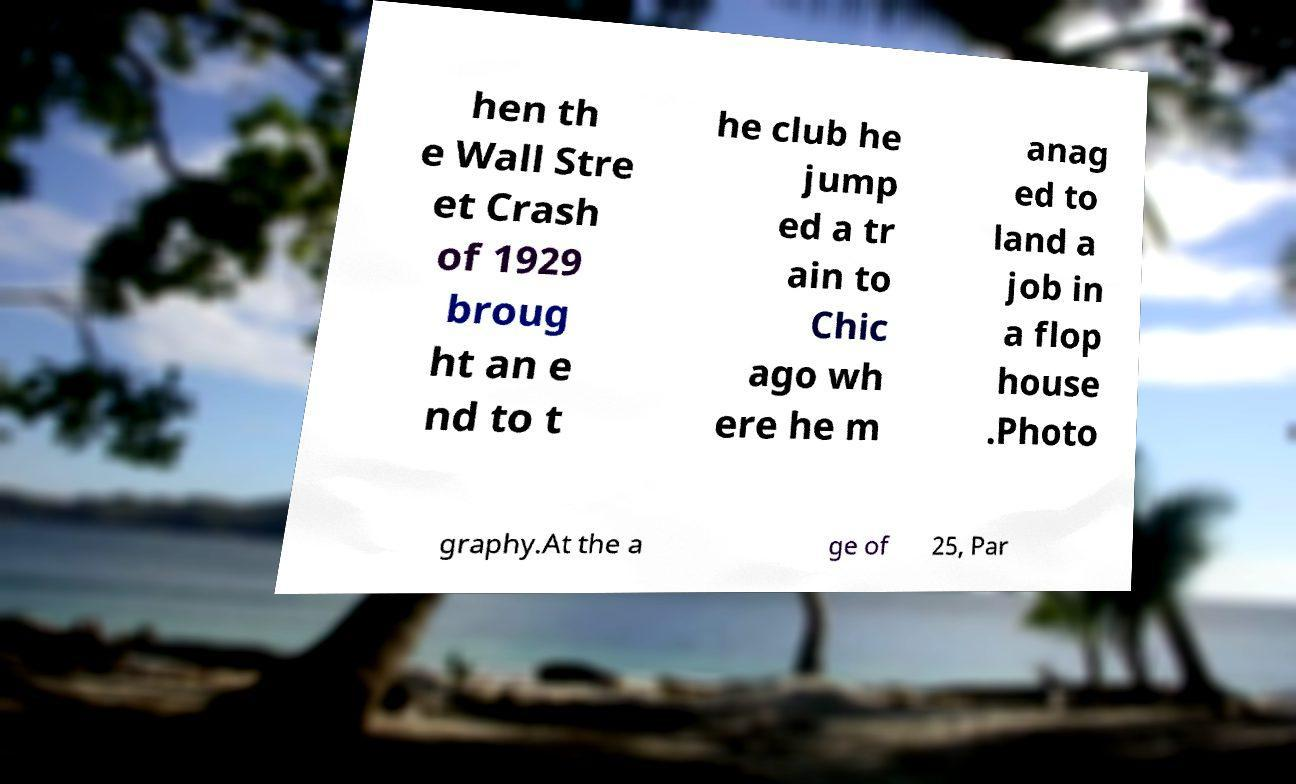Can you read and provide the text displayed in the image?This photo seems to have some interesting text. Can you extract and type it out for me? hen th e Wall Stre et Crash of 1929 broug ht an e nd to t he club he jump ed a tr ain to Chic ago wh ere he m anag ed to land a job in a flop house .Photo graphy.At the a ge of 25, Par 